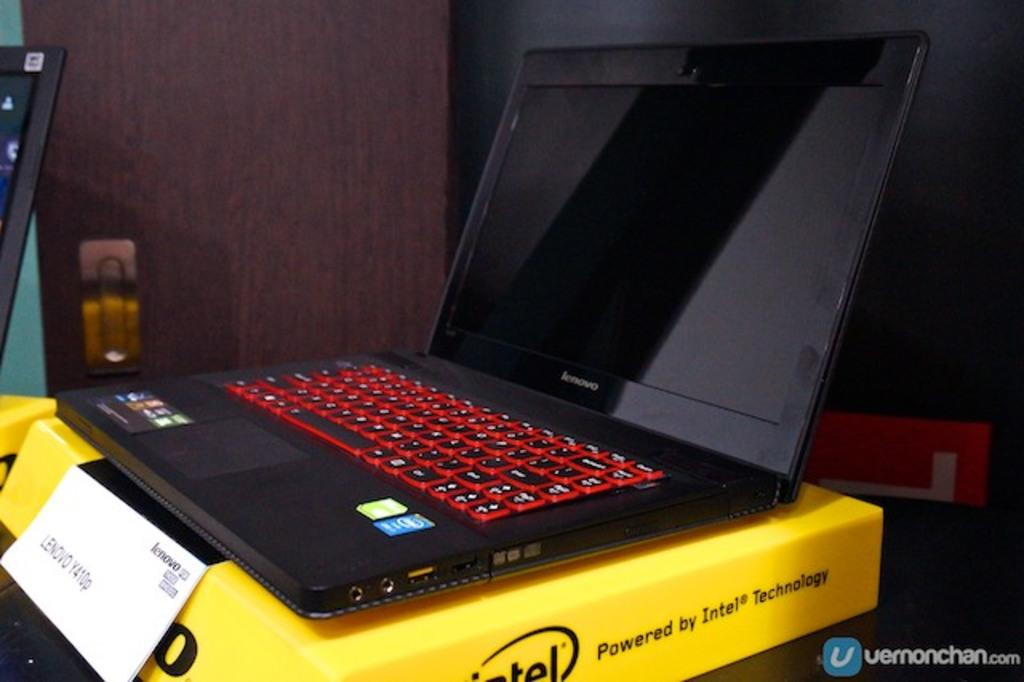<image>
Provide a brief description of the given image. the word powered is on some yellow box with a laptop on it 